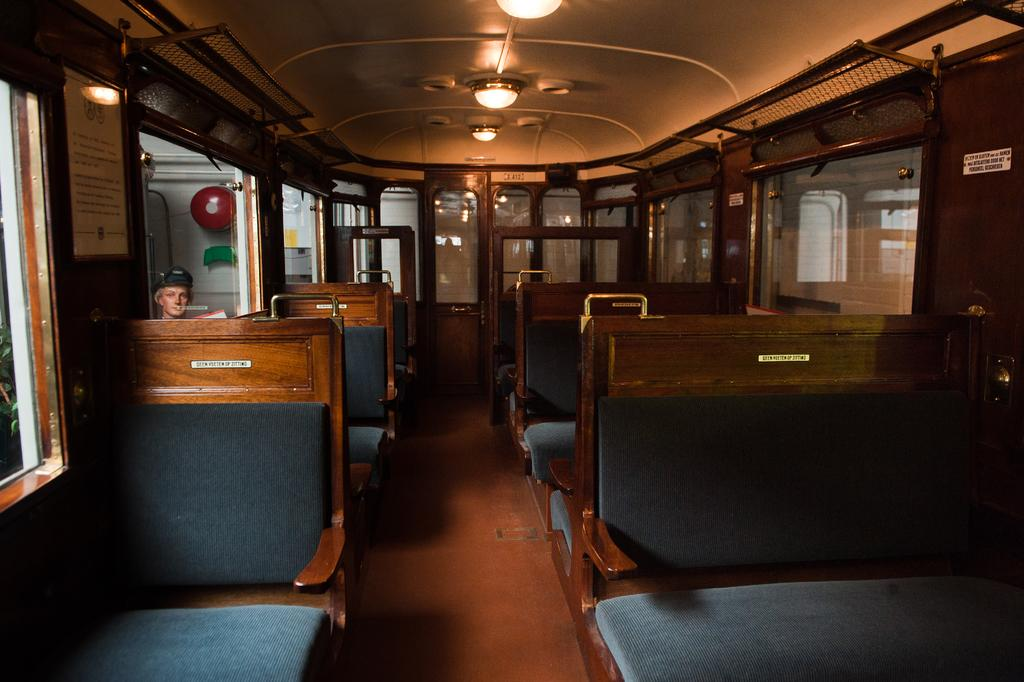What is the setting of the image? The image is taken inside a vehicle. What can be found inside the vehicle? There are seats in the vehicle. Is there anyone present in the image? Yes, there is a person in the image. What can be seen in terms of lighting in the image? There are lights visible in the image. What else is visible in the image besides the person and lights? There are boards visible in the image. How many pumps are visible in the image? There are no pumps present in the image. What type of polish is being applied to the boards in the image? There is no polish or application process visible in the image; only the boards are present. 